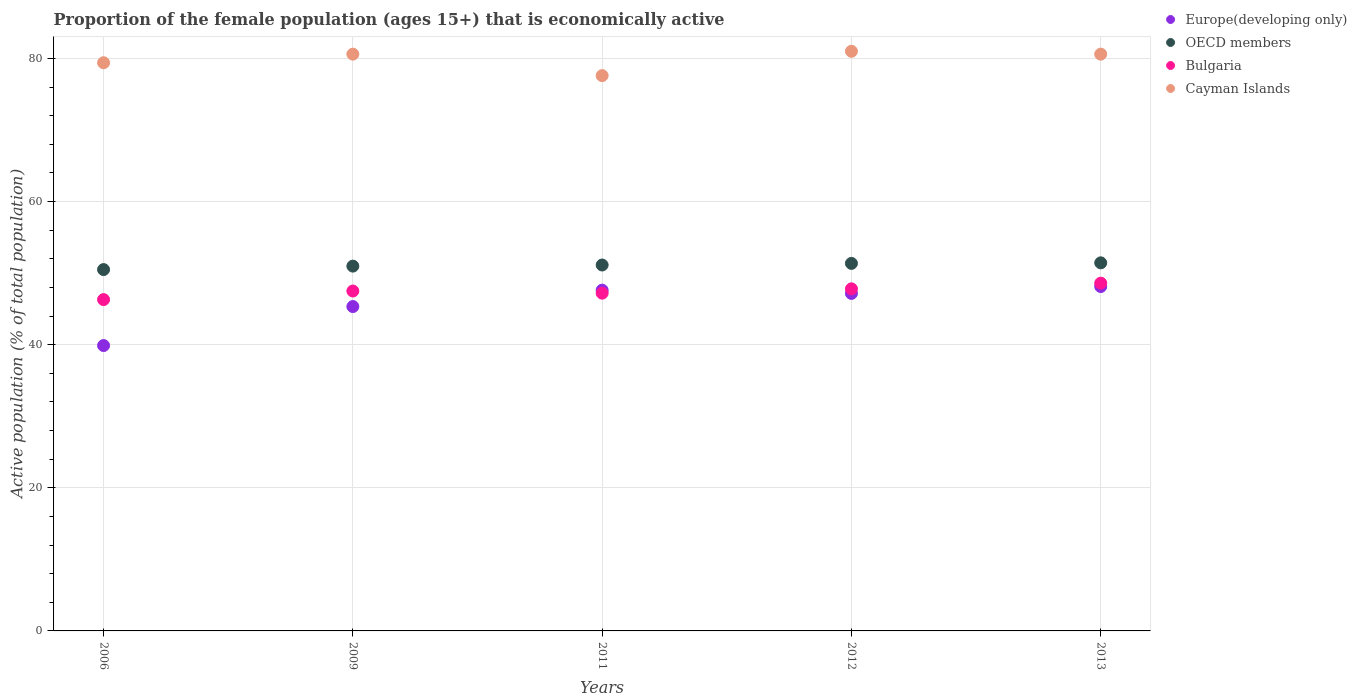How many different coloured dotlines are there?
Offer a very short reply. 4. Is the number of dotlines equal to the number of legend labels?
Keep it short and to the point. Yes. What is the proportion of the female population that is economically active in Cayman Islands in 2009?
Ensure brevity in your answer.  80.6. Across all years, what is the maximum proportion of the female population that is economically active in Cayman Islands?
Your answer should be compact. 81. Across all years, what is the minimum proportion of the female population that is economically active in Europe(developing only)?
Keep it short and to the point. 39.88. What is the total proportion of the female population that is economically active in OECD members in the graph?
Offer a terse response. 255.41. What is the difference between the proportion of the female population that is economically active in Europe(developing only) in 2006 and that in 2012?
Make the answer very short. -7.29. What is the difference between the proportion of the female population that is economically active in OECD members in 2011 and the proportion of the female population that is economically active in Europe(developing only) in 2012?
Provide a succinct answer. 3.97. What is the average proportion of the female population that is economically active in OECD members per year?
Provide a succinct answer. 51.08. In the year 2011, what is the difference between the proportion of the female population that is economically active in OECD members and proportion of the female population that is economically active in Cayman Islands?
Offer a very short reply. -26.47. What is the ratio of the proportion of the female population that is economically active in Cayman Islands in 2009 to that in 2013?
Offer a terse response. 1. Is the proportion of the female population that is economically active in Bulgaria in 2012 less than that in 2013?
Offer a very short reply. Yes. Is the difference between the proportion of the female population that is economically active in OECD members in 2009 and 2012 greater than the difference between the proportion of the female population that is economically active in Cayman Islands in 2009 and 2012?
Your response must be concise. Yes. What is the difference between the highest and the second highest proportion of the female population that is economically active in OECD members?
Ensure brevity in your answer.  0.08. What is the difference between the highest and the lowest proportion of the female population that is economically active in Europe(developing only)?
Offer a very short reply. 8.25. Is the sum of the proportion of the female population that is economically active in OECD members in 2006 and 2011 greater than the maximum proportion of the female population that is economically active in Europe(developing only) across all years?
Your answer should be compact. Yes. Is it the case that in every year, the sum of the proportion of the female population that is economically active in OECD members and proportion of the female population that is economically active in Europe(developing only)  is greater than the proportion of the female population that is economically active in Bulgaria?
Your response must be concise. Yes. Does the proportion of the female population that is economically active in OECD members monotonically increase over the years?
Keep it short and to the point. Yes. Is the proportion of the female population that is economically active in Bulgaria strictly greater than the proportion of the female population that is economically active in Cayman Islands over the years?
Offer a terse response. No. How many years are there in the graph?
Provide a short and direct response. 5. Are the values on the major ticks of Y-axis written in scientific E-notation?
Offer a very short reply. No. Does the graph contain any zero values?
Give a very brief answer. No. How many legend labels are there?
Offer a terse response. 4. How are the legend labels stacked?
Offer a terse response. Vertical. What is the title of the graph?
Give a very brief answer. Proportion of the female population (ages 15+) that is economically active. What is the label or title of the Y-axis?
Ensure brevity in your answer.  Active population (% of total population). What is the Active population (% of total population) in Europe(developing only) in 2006?
Offer a terse response. 39.88. What is the Active population (% of total population) of OECD members in 2006?
Your answer should be very brief. 50.5. What is the Active population (% of total population) in Bulgaria in 2006?
Keep it short and to the point. 46.3. What is the Active population (% of total population) of Cayman Islands in 2006?
Give a very brief answer. 79.4. What is the Active population (% of total population) of Europe(developing only) in 2009?
Your answer should be compact. 45.33. What is the Active population (% of total population) of OECD members in 2009?
Your answer should be very brief. 50.98. What is the Active population (% of total population) in Bulgaria in 2009?
Make the answer very short. 47.5. What is the Active population (% of total population) of Cayman Islands in 2009?
Make the answer very short. 80.6. What is the Active population (% of total population) in Europe(developing only) in 2011?
Give a very brief answer. 47.62. What is the Active population (% of total population) of OECD members in 2011?
Your answer should be compact. 51.13. What is the Active population (% of total population) of Bulgaria in 2011?
Your answer should be compact. 47.2. What is the Active population (% of total population) in Cayman Islands in 2011?
Provide a short and direct response. 77.6. What is the Active population (% of total population) in Europe(developing only) in 2012?
Your response must be concise. 47.16. What is the Active population (% of total population) of OECD members in 2012?
Your answer should be compact. 51.36. What is the Active population (% of total population) in Bulgaria in 2012?
Provide a short and direct response. 47.8. What is the Active population (% of total population) in Cayman Islands in 2012?
Your response must be concise. 81. What is the Active population (% of total population) in Europe(developing only) in 2013?
Keep it short and to the point. 48.12. What is the Active population (% of total population) in OECD members in 2013?
Make the answer very short. 51.44. What is the Active population (% of total population) of Bulgaria in 2013?
Ensure brevity in your answer.  48.6. What is the Active population (% of total population) of Cayman Islands in 2013?
Your answer should be very brief. 80.6. Across all years, what is the maximum Active population (% of total population) in Europe(developing only)?
Give a very brief answer. 48.12. Across all years, what is the maximum Active population (% of total population) in OECD members?
Your answer should be very brief. 51.44. Across all years, what is the maximum Active population (% of total population) of Bulgaria?
Keep it short and to the point. 48.6. Across all years, what is the maximum Active population (% of total population) of Cayman Islands?
Your answer should be very brief. 81. Across all years, what is the minimum Active population (% of total population) of Europe(developing only)?
Your response must be concise. 39.88. Across all years, what is the minimum Active population (% of total population) in OECD members?
Your answer should be compact. 50.5. Across all years, what is the minimum Active population (% of total population) of Bulgaria?
Your answer should be compact. 46.3. Across all years, what is the minimum Active population (% of total population) of Cayman Islands?
Give a very brief answer. 77.6. What is the total Active population (% of total population) in Europe(developing only) in the graph?
Ensure brevity in your answer.  228.12. What is the total Active population (% of total population) of OECD members in the graph?
Your answer should be very brief. 255.41. What is the total Active population (% of total population) of Bulgaria in the graph?
Your answer should be compact. 237.4. What is the total Active population (% of total population) of Cayman Islands in the graph?
Ensure brevity in your answer.  399.2. What is the difference between the Active population (% of total population) of Europe(developing only) in 2006 and that in 2009?
Offer a very short reply. -5.45. What is the difference between the Active population (% of total population) of OECD members in 2006 and that in 2009?
Offer a very short reply. -0.48. What is the difference between the Active population (% of total population) in Bulgaria in 2006 and that in 2009?
Your response must be concise. -1.2. What is the difference between the Active population (% of total population) in Europe(developing only) in 2006 and that in 2011?
Make the answer very short. -7.75. What is the difference between the Active population (% of total population) of OECD members in 2006 and that in 2011?
Give a very brief answer. -0.64. What is the difference between the Active population (% of total population) of Bulgaria in 2006 and that in 2011?
Provide a succinct answer. -0.9. What is the difference between the Active population (% of total population) in Cayman Islands in 2006 and that in 2011?
Your answer should be very brief. 1.8. What is the difference between the Active population (% of total population) in Europe(developing only) in 2006 and that in 2012?
Provide a succinct answer. -7.29. What is the difference between the Active population (% of total population) of OECD members in 2006 and that in 2012?
Offer a very short reply. -0.86. What is the difference between the Active population (% of total population) of Europe(developing only) in 2006 and that in 2013?
Your answer should be very brief. -8.25. What is the difference between the Active population (% of total population) in OECD members in 2006 and that in 2013?
Offer a terse response. -0.94. What is the difference between the Active population (% of total population) of Bulgaria in 2006 and that in 2013?
Offer a terse response. -2.3. What is the difference between the Active population (% of total population) in Cayman Islands in 2006 and that in 2013?
Provide a short and direct response. -1.2. What is the difference between the Active population (% of total population) of Europe(developing only) in 2009 and that in 2011?
Offer a terse response. -2.29. What is the difference between the Active population (% of total population) of OECD members in 2009 and that in 2011?
Your answer should be compact. -0.16. What is the difference between the Active population (% of total population) in Bulgaria in 2009 and that in 2011?
Offer a very short reply. 0.3. What is the difference between the Active population (% of total population) of Europe(developing only) in 2009 and that in 2012?
Your response must be concise. -1.83. What is the difference between the Active population (% of total population) of OECD members in 2009 and that in 2012?
Keep it short and to the point. -0.38. What is the difference between the Active population (% of total population) of Bulgaria in 2009 and that in 2012?
Your response must be concise. -0.3. What is the difference between the Active population (% of total population) in Cayman Islands in 2009 and that in 2012?
Your answer should be compact. -0.4. What is the difference between the Active population (% of total population) of Europe(developing only) in 2009 and that in 2013?
Offer a terse response. -2.79. What is the difference between the Active population (% of total population) in OECD members in 2009 and that in 2013?
Offer a very short reply. -0.46. What is the difference between the Active population (% of total population) of Cayman Islands in 2009 and that in 2013?
Offer a terse response. 0. What is the difference between the Active population (% of total population) in Europe(developing only) in 2011 and that in 2012?
Offer a terse response. 0.46. What is the difference between the Active population (% of total population) in OECD members in 2011 and that in 2012?
Keep it short and to the point. -0.23. What is the difference between the Active population (% of total population) of Europe(developing only) in 2011 and that in 2013?
Offer a terse response. -0.5. What is the difference between the Active population (% of total population) in OECD members in 2011 and that in 2013?
Ensure brevity in your answer.  -0.3. What is the difference between the Active population (% of total population) in Europe(developing only) in 2012 and that in 2013?
Offer a very short reply. -0.96. What is the difference between the Active population (% of total population) in OECD members in 2012 and that in 2013?
Your answer should be very brief. -0.08. What is the difference between the Active population (% of total population) of Cayman Islands in 2012 and that in 2013?
Offer a very short reply. 0.4. What is the difference between the Active population (% of total population) of Europe(developing only) in 2006 and the Active population (% of total population) of OECD members in 2009?
Your response must be concise. -11.1. What is the difference between the Active population (% of total population) in Europe(developing only) in 2006 and the Active population (% of total population) in Bulgaria in 2009?
Offer a terse response. -7.62. What is the difference between the Active population (% of total population) of Europe(developing only) in 2006 and the Active population (% of total population) of Cayman Islands in 2009?
Your response must be concise. -40.72. What is the difference between the Active population (% of total population) in OECD members in 2006 and the Active population (% of total population) in Bulgaria in 2009?
Keep it short and to the point. 3. What is the difference between the Active population (% of total population) of OECD members in 2006 and the Active population (% of total population) of Cayman Islands in 2009?
Offer a terse response. -30.1. What is the difference between the Active population (% of total population) in Bulgaria in 2006 and the Active population (% of total population) in Cayman Islands in 2009?
Offer a very short reply. -34.3. What is the difference between the Active population (% of total population) of Europe(developing only) in 2006 and the Active population (% of total population) of OECD members in 2011?
Provide a succinct answer. -11.26. What is the difference between the Active population (% of total population) of Europe(developing only) in 2006 and the Active population (% of total population) of Bulgaria in 2011?
Provide a short and direct response. -7.32. What is the difference between the Active population (% of total population) in Europe(developing only) in 2006 and the Active population (% of total population) in Cayman Islands in 2011?
Keep it short and to the point. -37.72. What is the difference between the Active population (% of total population) of OECD members in 2006 and the Active population (% of total population) of Bulgaria in 2011?
Provide a succinct answer. 3.3. What is the difference between the Active population (% of total population) of OECD members in 2006 and the Active population (% of total population) of Cayman Islands in 2011?
Ensure brevity in your answer.  -27.1. What is the difference between the Active population (% of total population) of Bulgaria in 2006 and the Active population (% of total population) of Cayman Islands in 2011?
Offer a terse response. -31.3. What is the difference between the Active population (% of total population) in Europe(developing only) in 2006 and the Active population (% of total population) in OECD members in 2012?
Your answer should be very brief. -11.48. What is the difference between the Active population (% of total population) in Europe(developing only) in 2006 and the Active population (% of total population) in Bulgaria in 2012?
Keep it short and to the point. -7.92. What is the difference between the Active population (% of total population) of Europe(developing only) in 2006 and the Active population (% of total population) of Cayman Islands in 2012?
Your answer should be compact. -41.12. What is the difference between the Active population (% of total population) of OECD members in 2006 and the Active population (% of total population) of Bulgaria in 2012?
Your answer should be very brief. 2.7. What is the difference between the Active population (% of total population) of OECD members in 2006 and the Active population (% of total population) of Cayman Islands in 2012?
Provide a short and direct response. -30.5. What is the difference between the Active population (% of total population) in Bulgaria in 2006 and the Active population (% of total population) in Cayman Islands in 2012?
Keep it short and to the point. -34.7. What is the difference between the Active population (% of total population) in Europe(developing only) in 2006 and the Active population (% of total population) in OECD members in 2013?
Offer a very short reply. -11.56. What is the difference between the Active population (% of total population) in Europe(developing only) in 2006 and the Active population (% of total population) in Bulgaria in 2013?
Your answer should be compact. -8.72. What is the difference between the Active population (% of total population) in Europe(developing only) in 2006 and the Active population (% of total population) in Cayman Islands in 2013?
Ensure brevity in your answer.  -40.72. What is the difference between the Active population (% of total population) of OECD members in 2006 and the Active population (% of total population) of Bulgaria in 2013?
Offer a very short reply. 1.9. What is the difference between the Active population (% of total population) of OECD members in 2006 and the Active population (% of total population) of Cayman Islands in 2013?
Ensure brevity in your answer.  -30.1. What is the difference between the Active population (% of total population) of Bulgaria in 2006 and the Active population (% of total population) of Cayman Islands in 2013?
Keep it short and to the point. -34.3. What is the difference between the Active population (% of total population) of Europe(developing only) in 2009 and the Active population (% of total population) of OECD members in 2011?
Your answer should be compact. -5.8. What is the difference between the Active population (% of total population) in Europe(developing only) in 2009 and the Active population (% of total population) in Bulgaria in 2011?
Your answer should be very brief. -1.87. What is the difference between the Active population (% of total population) in Europe(developing only) in 2009 and the Active population (% of total population) in Cayman Islands in 2011?
Your response must be concise. -32.27. What is the difference between the Active population (% of total population) in OECD members in 2009 and the Active population (% of total population) in Bulgaria in 2011?
Offer a terse response. 3.78. What is the difference between the Active population (% of total population) of OECD members in 2009 and the Active population (% of total population) of Cayman Islands in 2011?
Your answer should be very brief. -26.62. What is the difference between the Active population (% of total population) in Bulgaria in 2009 and the Active population (% of total population) in Cayman Islands in 2011?
Keep it short and to the point. -30.1. What is the difference between the Active population (% of total population) of Europe(developing only) in 2009 and the Active population (% of total population) of OECD members in 2012?
Ensure brevity in your answer.  -6.03. What is the difference between the Active population (% of total population) of Europe(developing only) in 2009 and the Active population (% of total population) of Bulgaria in 2012?
Give a very brief answer. -2.47. What is the difference between the Active population (% of total population) of Europe(developing only) in 2009 and the Active population (% of total population) of Cayman Islands in 2012?
Offer a very short reply. -35.67. What is the difference between the Active population (% of total population) of OECD members in 2009 and the Active population (% of total population) of Bulgaria in 2012?
Your response must be concise. 3.18. What is the difference between the Active population (% of total population) in OECD members in 2009 and the Active population (% of total population) in Cayman Islands in 2012?
Give a very brief answer. -30.02. What is the difference between the Active population (% of total population) of Bulgaria in 2009 and the Active population (% of total population) of Cayman Islands in 2012?
Ensure brevity in your answer.  -33.5. What is the difference between the Active population (% of total population) in Europe(developing only) in 2009 and the Active population (% of total population) in OECD members in 2013?
Your answer should be compact. -6.11. What is the difference between the Active population (% of total population) in Europe(developing only) in 2009 and the Active population (% of total population) in Bulgaria in 2013?
Ensure brevity in your answer.  -3.27. What is the difference between the Active population (% of total population) in Europe(developing only) in 2009 and the Active population (% of total population) in Cayman Islands in 2013?
Keep it short and to the point. -35.27. What is the difference between the Active population (% of total population) of OECD members in 2009 and the Active population (% of total population) of Bulgaria in 2013?
Ensure brevity in your answer.  2.38. What is the difference between the Active population (% of total population) in OECD members in 2009 and the Active population (% of total population) in Cayman Islands in 2013?
Your answer should be very brief. -29.62. What is the difference between the Active population (% of total population) of Bulgaria in 2009 and the Active population (% of total population) of Cayman Islands in 2013?
Ensure brevity in your answer.  -33.1. What is the difference between the Active population (% of total population) of Europe(developing only) in 2011 and the Active population (% of total population) of OECD members in 2012?
Your answer should be very brief. -3.74. What is the difference between the Active population (% of total population) in Europe(developing only) in 2011 and the Active population (% of total population) in Bulgaria in 2012?
Give a very brief answer. -0.18. What is the difference between the Active population (% of total population) of Europe(developing only) in 2011 and the Active population (% of total population) of Cayman Islands in 2012?
Your answer should be compact. -33.38. What is the difference between the Active population (% of total population) of OECD members in 2011 and the Active population (% of total population) of Bulgaria in 2012?
Your answer should be very brief. 3.33. What is the difference between the Active population (% of total population) of OECD members in 2011 and the Active population (% of total population) of Cayman Islands in 2012?
Make the answer very short. -29.86. What is the difference between the Active population (% of total population) in Bulgaria in 2011 and the Active population (% of total population) in Cayman Islands in 2012?
Provide a succinct answer. -33.8. What is the difference between the Active population (% of total population) in Europe(developing only) in 2011 and the Active population (% of total population) in OECD members in 2013?
Your response must be concise. -3.81. What is the difference between the Active population (% of total population) in Europe(developing only) in 2011 and the Active population (% of total population) in Bulgaria in 2013?
Provide a succinct answer. -0.98. What is the difference between the Active population (% of total population) of Europe(developing only) in 2011 and the Active population (% of total population) of Cayman Islands in 2013?
Make the answer very short. -32.98. What is the difference between the Active population (% of total population) of OECD members in 2011 and the Active population (% of total population) of Bulgaria in 2013?
Give a very brief answer. 2.54. What is the difference between the Active population (% of total population) of OECD members in 2011 and the Active population (% of total population) of Cayman Islands in 2013?
Your response must be concise. -29.46. What is the difference between the Active population (% of total population) in Bulgaria in 2011 and the Active population (% of total population) in Cayman Islands in 2013?
Provide a succinct answer. -33.4. What is the difference between the Active population (% of total population) of Europe(developing only) in 2012 and the Active population (% of total population) of OECD members in 2013?
Offer a very short reply. -4.27. What is the difference between the Active population (% of total population) in Europe(developing only) in 2012 and the Active population (% of total population) in Bulgaria in 2013?
Your answer should be very brief. -1.44. What is the difference between the Active population (% of total population) in Europe(developing only) in 2012 and the Active population (% of total population) in Cayman Islands in 2013?
Provide a short and direct response. -33.44. What is the difference between the Active population (% of total population) in OECD members in 2012 and the Active population (% of total population) in Bulgaria in 2013?
Your response must be concise. 2.76. What is the difference between the Active population (% of total population) of OECD members in 2012 and the Active population (% of total population) of Cayman Islands in 2013?
Your answer should be compact. -29.24. What is the difference between the Active population (% of total population) in Bulgaria in 2012 and the Active population (% of total population) in Cayman Islands in 2013?
Your response must be concise. -32.8. What is the average Active population (% of total population) in Europe(developing only) per year?
Offer a terse response. 45.62. What is the average Active population (% of total population) in OECD members per year?
Keep it short and to the point. 51.08. What is the average Active population (% of total population) of Bulgaria per year?
Give a very brief answer. 47.48. What is the average Active population (% of total population) of Cayman Islands per year?
Offer a very short reply. 79.84. In the year 2006, what is the difference between the Active population (% of total population) of Europe(developing only) and Active population (% of total population) of OECD members?
Your answer should be very brief. -10.62. In the year 2006, what is the difference between the Active population (% of total population) in Europe(developing only) and Active population (% of total population) in Bulgaria?
Your response must be concise. -6.42. In the year 2006, what is the difference between the Active population (% of total population) in Europe(developing only) and Active population (% of total population) in Cayman Islands?
Ensure brevity in your answer.  -39.52. In the year 2006, what is the difference between the Active population (% of total population) of OECD members and Active population (% of total population) of Bulgaria?
Your response must be concise. 4.2. In the year 2006, what is the difference between the Active population (% of total population) in OECD members and Active population (% of total population) in Cayman Islands?
Provide a short and direct response. -28.9. In the year 2006, what is the difference between the Active population (% of total population) of Bulgaria and Active population (% of total population) of Cayman Islands?
Provide a succinct answer. -33.1. In the year 2009, what is the difference between the Active population (% of total population) of Europe(developing only) and Active population (% of total population) of OECD members?
Your answer should be very brief. -5.65. In the year 2009, what is the difference between the Active population (% of total population) in Europe(developing only) and Active population (% of total population) in Bulgaria?
Keep it short and to the point. -2.17. In the year 2009, what is the difference between the Active population (% of total population) of Europe(developing only) and Active population (% of total population) of Cayman Islands?
Offer a terse response. -35.27. In the year 2009, what is the difference between the Active population (% of total population) of OECD members and Active population (% of total population) of Bulgaria?
Give a very brief answer. 3.48. In the year 2009, what is the difference between the Active population (% of total population) in OECD members and Active population (% of total population) in Cayman Islands?
Offer a very short reply. -29.62. In the year 2009, what is the difference between the Active population (% of total population) in Bulgaria and Active population (% of total population) in Cayman Islands?
Make the answer very short. -33.1. In the year 2011, what is the difference between the Active population (% of total population) of Europe(developing only) and Active population (% of total population) of OECD members?
Offer a terse response. -3.51. In the year 2011, what is the difference between the Active population (% of total population) of Europe(developing only) and Active population (% of total population) of Bulgaria?
Make the answer very short. 0.42. In the year 2011, what is the difference between the Active population (% of total population) in Europe(developing only) and Active population (% of total population) in Cayman Islands?
Make the answer very short. -29.98. In the year 2011, what is the difference between the Active population (% of total population) in OECD members and Active population (% of total population) in Bulgaria?
Your response must be concise. 3.94. In the year 2011, what is the difference between the Active population (% of total population) in OECD members and Active population (% of total population) in Cayman Islands?
Provide a succinct answer. -26.46. In the year 2011, what is the difference between the Active population (% of total population) of Bulgaria and Active population (% of total population) of Cayman Islands?
Provide a succinct answer. -30.4. In the year 2012, what is the difference between the Active population (% of total population) of Europe(developing only) and Active population (% of total population) of OECD members?
Give a very brief answer. -4.2. In the year 2012, what is the difference between the Active population (% of total population) in Europe(developing only) and Active population (% of total population) in Bulgaria?
Offer a very short reply. -0.64. In the year 2012, what is the difference between the Active population (% of total population) in Europe(developing only) and Active population (% of total population) in Cayman Islands?
Offer a very short reply. -33.84. In the year 2012, what is the difference between the Active population (% of total population) of OECD members and Active population (% of total population) of Bulgaria?
Offer a terse response. 3.56. In the year 2012, what is the difference between the Active population (% of total population) of OECD members and Active population (% of total population) of Cayman Islands?
Keep it short and to the point. -29.64. In the year 2012, what is the difference between the Active population (% of total population) in Bulgaria and Active population (% of total population) in Cayman Islands?
Your answer should be very brief. -33.2. In the year 2013, what is the difference between the Active population (% of total population) in Europe(developing only) and Active population (% of total population) in OECD members?
Give a very brief answer. -3.31. In the year 2013, what is the difference between the Active population (% of total population) of Europe(developing only) and Active population (% of total population) of Bulgaria?
Ensure brevity in your answer.  -0.48. In the year 2013, what is the difference between the Active population (% of total population) of Europe(developing only) and Active population (% of total population) of Cayman Islands?
Your response must be concise. -32.48. In the year 2013, what is the difference between the Active population (% of total population) in OECD members and Active population (% of total population) in Bulgaria?
Make the answer very short. 2.84. In the year 2013, what is the difference between the Active population (% of total population) of OECD members and Active population (% of total population) of Cayman Islands?
Give a very brief answer. -29.16. In the year 2013, what is the difference between the Active population (% of total population) in Bulgaria and Active population (% of total population) in Cayman Islands?
Make the answer very short. -32. What is the ratio of the Active population (% of total population) of Europe(developing only) in 2006 to that in 2009?
Your answer should be compact. 0.88. What is the ratio of the Active population (% of total population) in Bulgaria in 2006 to that in 2009?
Your answer should be very brief. 0.97. What is the ratio of the Active population (% of total population) of Cayman Islands in 2006 to that in 2009?
Provide a succinct answer. 0.99. What is the ratio of the Active population (% of total population) in Europe(developing only) in 2006 to that in 2011?
Make the answer very short. 0.84. What is the ratio of the Active population (% of total population) in OECD members in 2006 to that in 2011?
Provide a short and direct response. 0.99. What is the ratio of the Active population (% of total population) of Bulgaria in 2006 to that in 2011?
Your response must be concise. 0.98. What is the ratio of the Active population (% of total population) in Cayman Islands in 2006 to that in 2011?
Give a very brief answer. 1.02. What is the ratio of the Active population (% of total population) of Europe(developing only) in 2006 to that in 2012?
Your answer should be very brief. 0.85. What is the ratio of the Active population (% of total population) in OECD members in 2006 to that in 2012?
Make the answer very short. 0.98. What is the ratio of the Active population (% of total population) in Bulgaria in 2006 to that in 2012?
Your answer should be compact. 0.97. What is the ratio of the Active population (% of total population) of Cayman Islands in 2006 to that in 2012?
Your answer should be compact. 0.98. What is the ratio of the Active population (% of total population) of Europe(developing only) in 2006 to that in 2013?
Your answer should be very brief. 0.83. What is the ratio of the Active population (% of total population) in OECD members in 2006 to that in 2013?
Your response must be concise. 0.98. What is the ratio of the Active population (% of total population) of Bulgaria in 2006 to that in 2013?
Provide a short and direct response. 0.95. What is the ratio of the Active population (% of total population) of Cayman Islands in 2006 to that in 2013?
Keep it short and to the point. 0.99. What is the ratio of the Active population (% of total population) of Europe(developing only) in 2009 to that in 2011?
Provide a succinct answer. 0.95. What is the ratio of the Active population (% of total population) of Bulgaria in 2009 to that in 2011?
Give a very brief answer. 1.01. What is the ratio of the Active population (% of total population) in Cayman Islands in 2009 to that in 2011?
Keep it short and to the point. 1.04. What is the ratio of the Active population (% of total population) in Europe(developing only) in 2009 to that in 2012?
Provide a succinct answer. 0.96. What is the ratio of the Active population (% of total population) of Europe(developing only) in 2009 to that in 2013?
Keep it short and to the point. 0.94. What is the ratio of the Active population (% of total population) in OECD members in 2009 to that in 2013?
Offer a very short reply. 0.99. What is the ratio of the Active population (% of total population) of Bulgaria in 2009 to that in 2013?
Your answer should be very brief. 0.98. What is the ratio of the Active population (% of total population) of Europe(developing only) in 2011 to that in 2012?
Provide a succinct answer. 1.01. What is the ratio of the Active population (% of total population) of OECD members in 2011 to that in 2012?
Offer a terse response. 1. What is the ratio of the Active population (% of total population) in Bulgaria in 2011 to that in 2012?
Provide a short and direct response. 0.99. What is the ratio of the Active population (% of total population) of Cayman Islands in 2011 to that in 2012?
Ensure brevity in your answer.  0.96. What is the ratio of the Active population (% of total population) in Europe(developing only) in 2011 to that in 2013?
Your answer should be very brief. 0.99. What is the ratio of the Active population (% of total population) in Bulgaria in 2011 to that in 2013?
Offer a very short reply. 0.97. What is the ratio of the Active population (% of total population) of Cayman Islands in 2011 to that in 2013?
Give a very brief answer. 0.96. What is the ratio of the Active population (% of total population) of Europe(developing only) in 2012 to that in 2013?
Your response must be concise. 0.98. What is the ratio of the Active population (% of total population) of OECD members in 2012 to that in 2013?
Your answer should be very brief. 1. What is the ratio of the Active population (% of total population) of Bulgaria in 2012 to that in 2013?
Your response must be concise. 0.98. What is the ratio of the Active population (% of total population) of Cayman Islands in 2012 to that in 2013?
Your answer should be very brief. 1. What is the difference between the highest and the second highest Active population (% of total population) of Europe(developing only)?
Offer a terse response. 0.5. What is the difference between the highest and the second highest Active population (% of total population) in OECD members?
Keep it short and to the point. 0.08. What is the difference between the highest and the second highest Active population (% of total population) of Bulgaria?
Make the answer very short. 0.8. What is the difference between the highest and the lowest Active population (% of total population) of Europe(developing only)?
Your answer should be very brief. 8.25. What is the difference between the highest and the lowest Active population (% of total population) of OECD members?
Give a very brief answer. 0.94. What is the difference between the highest and the lowest Active population (% of total population) in Cayman Islands?
Offer a very short reply. 3.4. 